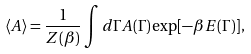Convert formula to latex. <formula><loc_0><loc_0><loc_500><loc_500>\langle A \rangle = { \frac { 1 } { Z ( \beta ) } } \int d \Gamma A ( \Gamma ) \exp [ - \beta E ( \Gamma ) ] ,</formula> 